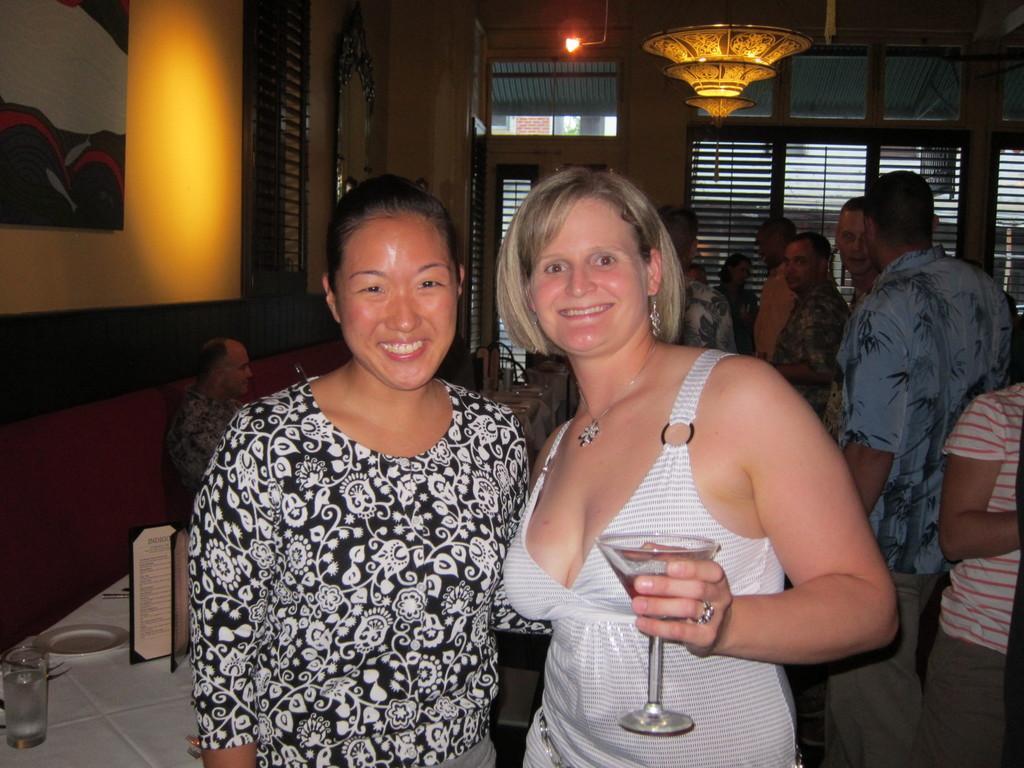In one or two sentences, can you explain what this image depicts? There is a woman wearing white dress is standing and holding a glass of drink in her hand in the right corner and there is another woman standing beside her and there are few people behind them. 